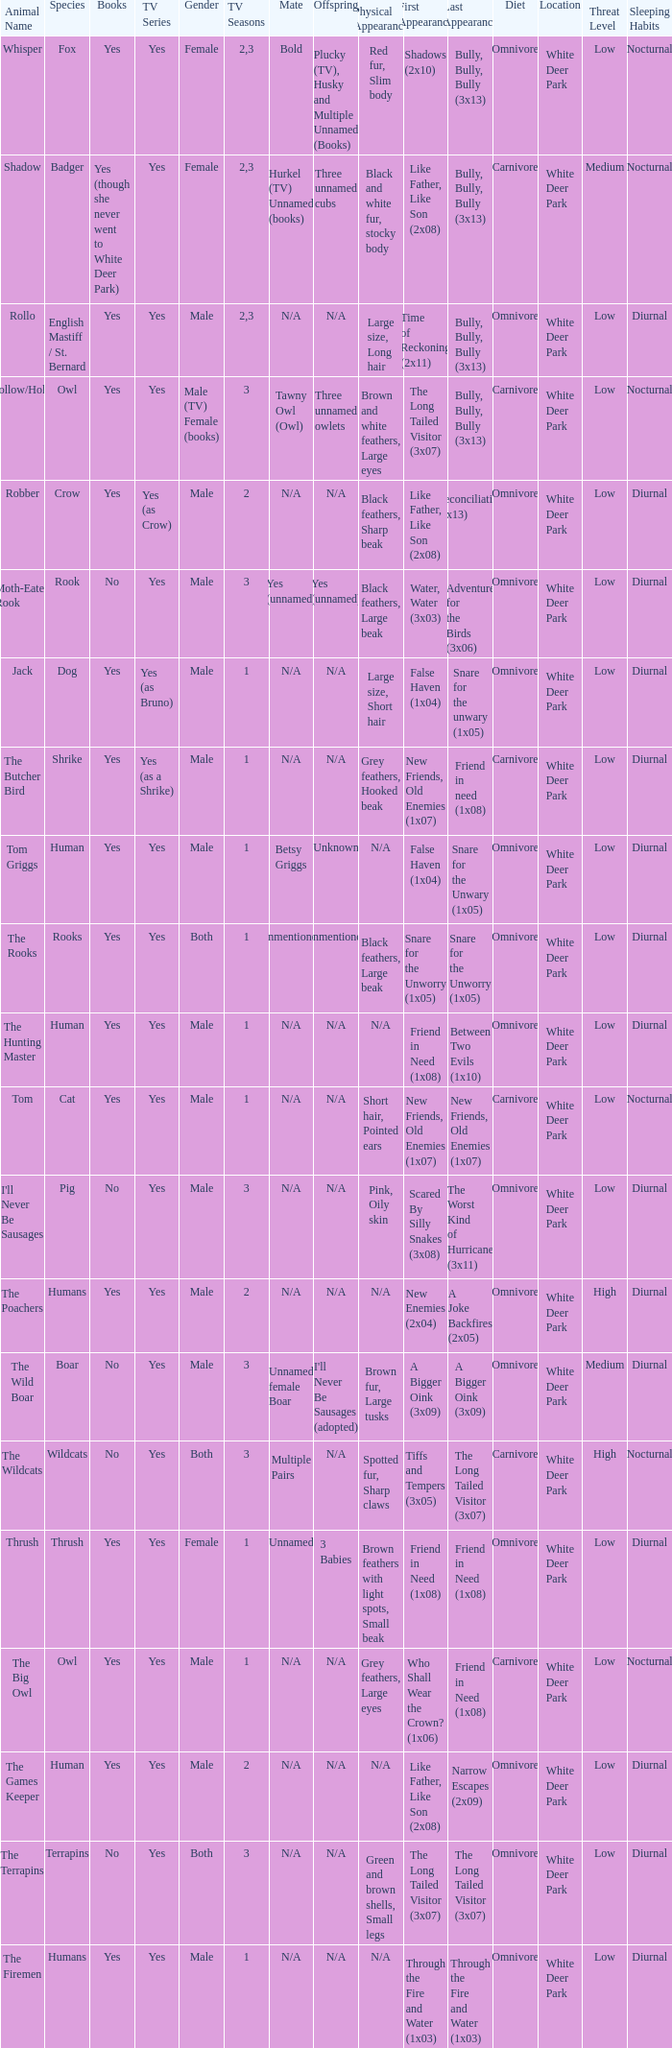What is the smallest season for a tv series with a yes and human was the species? 1.0. 